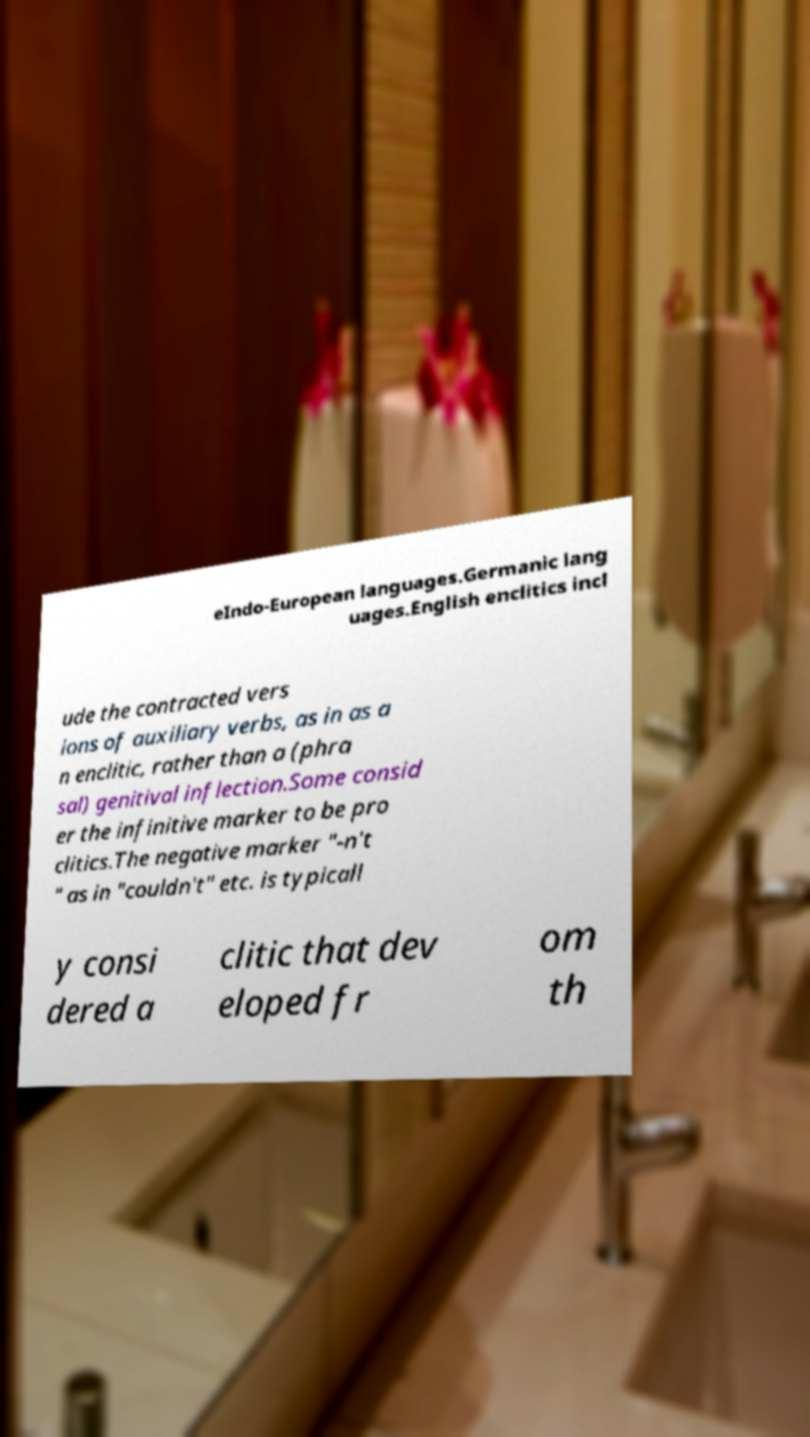Can you accurately transcribe the text from the provided image for me? eIndo-European languages.Germanic lang uages.English enclitics incl ude the contracted vers ions of auxiliary verbs, as in as a n enclitic, rather than a (phra sal) genitival inflection.Some consid er the infinitive marker to be pro clitics.The negative marker "-n't " as in "couldn't" etc. is typicall y consi dered a clitic that dev eloped fr om th 